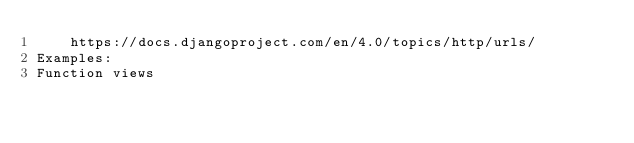<code> <loc_0><loc_0><loc_500><loc_500><_Python_>    https://docs.djangoproject.com/en/4.0/topics/http/urls/
Examples:
Function views</code> 